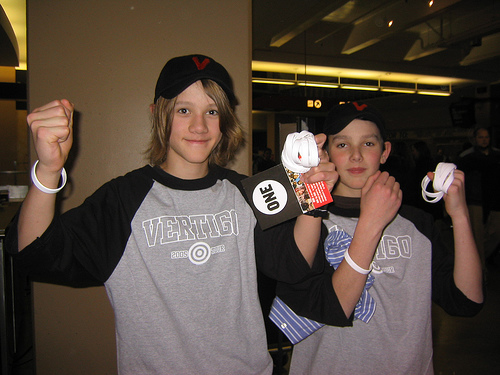<image>
Is the boy in front of the boy? Yes. The boy is positioned in front of the boy, appearing closer to the camera viewpoint. 